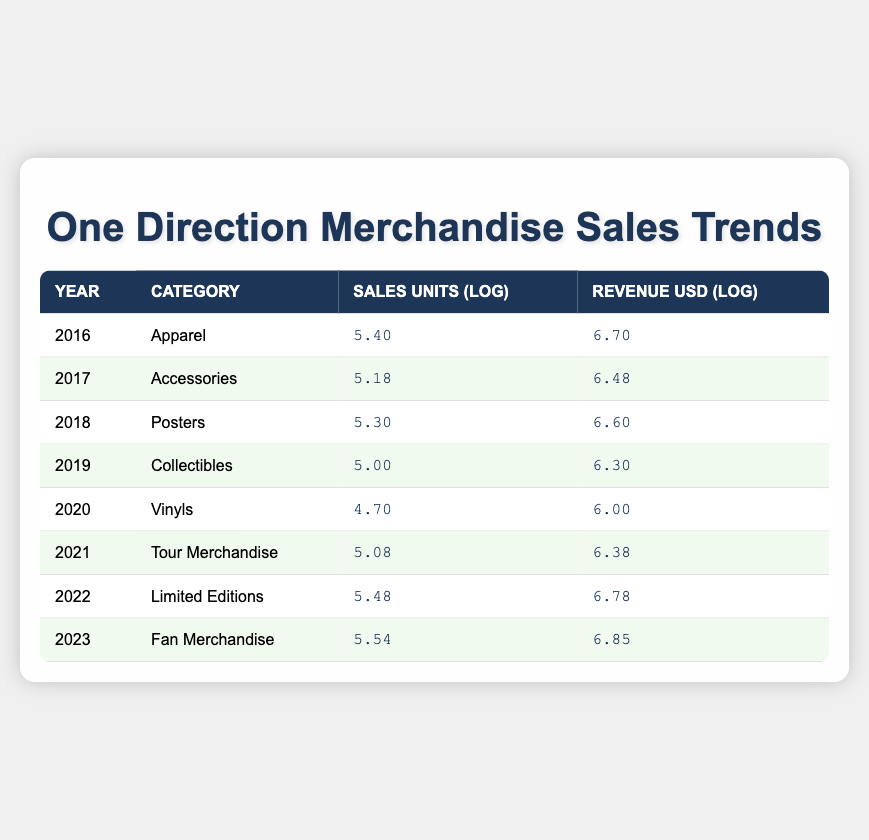What year had the highest revenue from merchandise sales? In the table, we can examine the revenue values for each year. The values are as follows: 2016 (6.70), 2017 (6.48), 2018 (6.60), 2019 (6.30), 2020 (6.00), 2021 (6.38), 2022 (6.78), and 2023 (6.85). Comparing these, 2023 has the highest log revenue value of 6.85.
Answer: 2023 Which merchandise category had the least sales units? By looking at the sales units for each category: Apparel (5.40), Accessories (5.18), Posters (5.30), Collectibles (5.00), Vinyls (4.70), Tour Merchandise (5.08), Limited Editions (5.48), and Fan Merchandise (5.54), the category with the least sales units is Vinyls, with a log value of 4.70.
Answer: Vinyls How many total sales units were recorded from 2016 to 2022? The sales units for each year are: 250000 (2016), 150000 (2017), 200000 (2018), 100000 (2019), 50000 (2020), 120000 (2021), and 300000 (2022). First, we sum these amounts: 250000 + 150000 + 200000 + 100000 + 50000 + 120000 + 300000 = 1075000.
Answer: 1075000 Was there a year where the sales units for merchandise exceeded 300000? Checking the sales unit values reveals: 250000 (2016), 150000 (2017), 200000 (2018), 100000 (2019), 50000 (2020), 120000 (2021), 300000 (2022), and 350000 (2023). The only year with sales units exceeding 300000 is 2023, which had 350000.
Answer: Yes What is the difference in log revenue between 2022 and 2021? The log revenue for 2022 is 6.78 and for 2021 is 6.38. To find the difference, we subtract: 6.78 - 6.38 = 0.40.
Answer: 0.40 